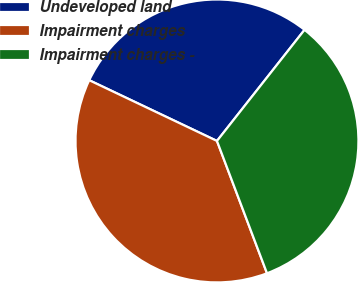Convert chart to OTSL. <chart><loc_0><loc_0><loc_500><loc_500><pie_chart><fcel>Undeveloped land<fcel>Impairment charges<fcel>Impairment charges -<nl><fcel>28.56%<fcel>37.82%<fcel>33.63%<nl></chart> 